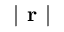Convert formula to latex. <formula><loc_0><loc_0><loc_500><loc_500>| r |</formula> 